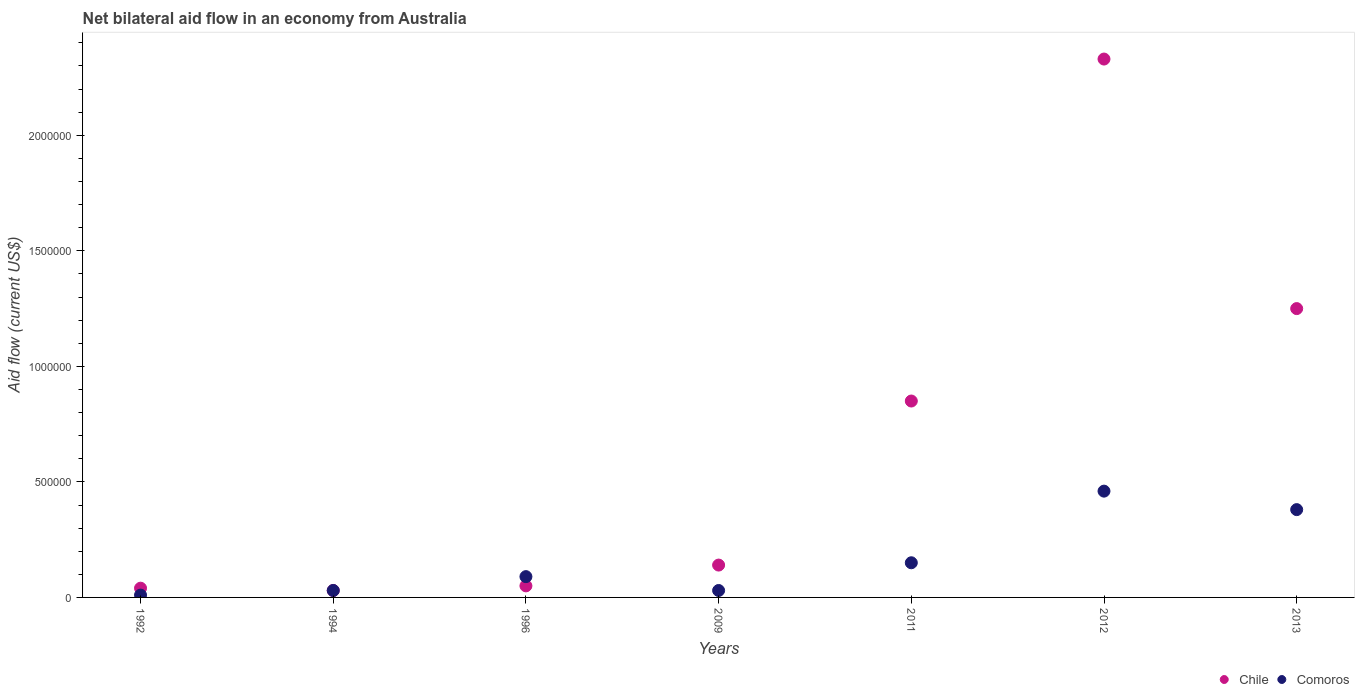What is the net bilateral aid flow in Chile in 2013?
Offer a very short reply. 1.25e+06. Across all years, what is the maximum net bilateral aid flow in Comoros?
Keep it short and to the point. 4.60e+05. In which year was the net bilateral aid flow in Comoros maximum?
Your answer should be compact. 2012. In which year was the net bilateral aid flow in Chile minimum?
Your answer should be compact. 1994. What is the total net bilateral aid flow in Chile in the graph?
Make the answer very short. 4.69e+06. What is the difference between the net bilateral aid flow in Chile in 2011 and the net bilateral aid flow in Comoros in 2013?
Your answer should be compact. 4.70e+05. What is the average net bilateral aid flow in Comoros per year?
Provide a short and direct response. 1.64e+05. What is the ratio of the net bilateral aid flow in Chile in 1992 to that in 2011?
Your answer should be compact. 0.05. What is the difference between the highest and the second highest net bilateral aid flow in Chile?
Your response must be concise. 1.08e+06. Is the sum of the net bilateral aid flow in Comoros in 2011 and 2013 greater than the maximum net bilateral aid flow in Chile across all years?
Offer a terse response. No. Does the net bilateral aid flow in Chile monotonically increase over the years?
Your answer should be compact. No. Is the net bilateral aid flow in Comoros strictly less than the net bilateral aid flow in Chile over the years?
Keep it short and to the point. No. How many legend labels are there?
Your answer should be compact. 2. What is the title of the graph?
Give a very brief answer. Net bilateral aid flow in an economy from Australia. What is the label or title of the Y-axis?
Ensure brevity in your answer.  Aid flow (current US$). What is the Aid flow (current US$) of Chile in 1992?
Provide a succinct answer. 4.00e+04. What is the Aid flow (current US$) in Comoros in 1992?
Offer a terse response. 10000. What is the Aid flow (current US$) in Chile in 1994?
Give a very brief answer. 3.00e+04. What is the Aid flow (current US$) in Comoros in 1994?
Make the answer very short. 3.00e+04. What is the Aid flow (current US$) of Comoros in 1996?
Offer a very short reply. 9.00e+04. What is the Aid flow (current US$) of Comoros in 2009?
Your answer should be compact. 3.00e+04. What is the Aid flow (current US$) in Chile in 2011?
Make the answer very short. 8.50e+05. What is the Aid flow (current US$) of Comoros in 2011?
Keep it short and to the point. 1.50e+05. What is the Aid flow (current US$) of Chile in 2012?
Your answer should be very brief. 2.33e+06. What is the Aid flow (current US$) of Comoros in 2012?
Ensure brevity in your answer.  4.60e+05. What is the Aid flow (current US$) in Chile in 2013?
Offer a terse response. 1.25e+06. Across all years, what is the maximum Aid flow (current US$) of Chile?
Your answer should be compact. 2.33e+06. Across all years, what is the minimum Aid flow (current US$) of Comoros?
Your response must be concise. 10000. What is the total Aid flow (current US$) in Chile in the graph?
Give a very brief answer. 4.69e+06. What is the total Aid flow (current US$) in Comoros in the graph?
Offer a very short reply. 1.15e+06. What is the difference between the Aid flow (current US$) of Chile in 1992 and that in 1994?
Keep it short and to the point. 10000. What is the difference between the Aid flow (current US$) in Chile in 1992 and that in 1996?
Keep it short and to the point. -10000. What is the difference between the Aid flow (current US$) of Chile in 1992 and that in 2011?
Your answer should be compact. -8.10e+05. What is the difference between the Aid flow (current US$) of Comoros in 1992 and that in 2011?
Provide a short and direct response. -1.40e+05. What is the difference between the Aid flow (current US$) in Chile in 1992 and that in 2012?
Your answer should be very brief. -2.29e+06. What is the difference between the Aid flow (current US$) in Comoros in 1992 and that in 2012?
Your answer should be very brief. -4.50e+05. What is the difference between the Aid flow (current US$) in Chile in 1992 and that in 2013?
Your answer should be very brief. -1.21e+06. What is the difference between the Aid flow (current US$) in Comoros in 1992 and that in 2013?
Provide a short and direct response. -3.70e+05. What is the difference between the Aid flow (current US$) of Chile in 1994 and that in 1996?
Your response must be concise. -2.00e+04. What is the difference between the Aid flow (current US$) in Comoros in 1994 and that in 1996?
Your answer should be compact. -6.00e+04. What is the difference between the Aid flow (current US$) in Chile in 1994 and that in 2009?
Ensure brevity in your answer.  -1.10e+05. What is the difference between the Aid flow (current US$) of Comoros in 1994 and that in 2009?
Provide a succinct answer. 0. What is the difference between the Aid flow (current US$) in Chile in 1994 and that in 2011?
Ensure brevity in your answer.  -8.20e+05. What is the difference between the Aid flow (current US$) in Comoros in 1994 and that in 2011?
Your response must be concise. -1.20e+05. What is the difference between the Aid flow (current US$) of Chile in 1994 and that in 2012?
Keep it short and to the point. -2.30e+06. What is the difference between the Aid flow (current US$) of Comoros in 1994 and that in 2012?
Provide a short and direct response. -4.30e+05. What is the difference between the Aid flow (current US$) in Chile in 1994 and that in 2013?
Make the answer very short. -1.22e+06. What is the difference between the Aid flow (current US$) of Comoros in 1994 and that in 2013?
Your response must be concise. -3.50e+05. What is the difference between the Aid flow (current US$) of Comoros in 1996 and that in 2009?
Your response must be concise. 6.00e+04. What is the difference between the Aid flow (current US$) of Chile in 1996 and that in 2011?
Provide a short and direct response. -8.00e+05. What is the difference between the Aid flow (current US$) of Chile in 1996 and that in 2012?
Give a very brief answer. -2.28e+06. What is the difference between the Aid flow (current US$) in Comoros in 1996 and that in 2012?
Provide a short and direct response. -3.70e+05. What is the difference between the Aid flow (current US$) of Chile in 1996 and that in 2013?
Make the answer very short. -1.20e+06. What is the difference between the Aid flow (current US$) in Comoros in 1996 and that in 2013?
Keep it short and to the point. -2.90e+05. What is the difference between the Aid flow (current US$) of Chile in 2009 and that in 2011?
Your response must be concise. -7.10e+05. What is the difference between the Aid flow (current US$) of Chile in 2009 and that in 2012?
Keep it short and to the point. -2.19e+06. What is the difference between the Aid flow (current US$) in Comoros in 2009 and that in 2012?
Ensure brevity in your answer.  -4.30e+05. What is the difference between the Aid flow (current US$) in Chile in 2009 and that in 2013?
Give a very brief answer. -1.11e+06. What is the difference between the Aid flow (current US$) of Comoros in 2009 and that in 2013?
Offer a terse response. -3.50e+05. What is the difference between the Aid flow (current US$) in Chile in 2011 and that in 2012?
Ensure brevity in your answer.  -1.48e+06. What is the difference between the Aid flow (current US$) in Comoros in 2011 and that in 2012?
Your answer should be very brief. -3.10e+05. What is the difference between the Aid flow (current US$) in Chile in 2011 and that in 2013?
Your answer should be very brief. -4.00e+05. What is the difference between the Aid flow (current US$) in Comoros in 2011 and that in 2013?
Ensure brevity in your answer.  -2.30e+05. What is the difference between the Aid flow (current US$) of Chile in 2012 and that in 2013?
Provide a short and direct response. 1.08e+06. What is the difference between the Aid flow (current US$) in Chile in 1992 and the Aid flow (current US$) in Comoros in 1994?
Make the answer very short. 10000. What is the difference between the Aid flow (current US$) of Chile in 1992 and the Aid flow (current US$) of Comoros in 2009?
Keep it short and to the point. 10000. What is the difference between the Aid flow (current US$) in Chile in 1992 and the Aid flow (current US$) in Comoros in 2011?
Your answer should be very brief. -1.10e+05. What is the difference between the Aid flow (current US$) in Chile in 1992 and the Aid flow (current US$) in Comoros in 2012?
Offer a terse response. -4.20e+05. What is the difference between the Aid flow (current US$) in Chile in 1994 and the Aid flow (current US$) in Comoros in 2012?
Offer a terse response. -4.30e+05. What is the difference between the Aid flow (current US$) of Chile in 1994 and the Aid flow (current US$) of Comoros in 2013?
Offer a very short reply. -3.50e+05. What is the difference between the Aid flow (current US$) in Chile in 1996 and the Aid flow (current US$) in Comoros in 2012?
Offer a very short reply. -4.10e+05. What is the difference between the Aid flow (current US$) in Chile in 1996 and the Aid flow (current US$) in Comoros in 2013?
Make the answer very short. -3.30e+05. What is the difference between the Aid flow (current US$) in Chile in 2009 and the Aid flow (current US$) in Comoros in 2011?
Make the answer very short. -10000. What is the difference between the Aid flow (current US$) in Chile in 2009 and the Aid flow (current US$) in Comoros in 2012?
Give a very brief answer. -3.20e+05. What is the difference between the Aid flow (current US$) in Chile in 2009 and the Aid flow (current US$) in Comoros in 2013?
Provide a short and direct response. -2.40e+05. What is the difference between the Aid flow (current US$) in Chile in 2011 and the Aid flow (current US$) in Comoros in 2012?
Your answer should be compact. 3.90e+05. What is the difference between the Aid flow (current US$) in Chile in 2012 and the Aid flow (current US$) in Comoros in 2013?
Offer a terse response. 1.95e+06. What is the average Aid flow (current US$) of Chile per year?
Ensure brevity in your answer.  6.70e+05. What is the average Aid flow (current US$) of Comoros per year?
Provide a succinct answer. 1.64e+05. In the year 1992, what is the difference between the Aid flow (current US$) in Chile and Aid flow (current US$) in Comoros?
Your answer should be compact. 3.00e+04. In the year 1996, what is the difference between the Aid flow (current US$) in Chile and Aid flow (current US$) in Comoros?
Your response must be concise. -4.00e+04. In the year 2009, what is the difference between the Aid flow (current US$) of Chile and Aid flow (current US$) of Comoros?
Keep it short and to the point. 1.10e+05. In the year 2012, what is the difference between the Aid flow (current US$) of Chile and Aid flow (current US$) of Comoros?
Your response must be concise. 1.87e+06. In the year 2013, what is the difference between the Aid flow (current US$) of Chile and Aid flow (current US$) of Comoros?
Keep it short and to the point. 8.70e+05. What is the ratio of the Aid flow (current US$) in Chile in 1992 to that in 1994?
Your answer should be compact. 1.33. What is the ratio of the Aid flow (current US$) of Comoros in 1992 to that in 1994?
Keep it short and to the point. 0.33. What is the ratio of the Aid flow (current US$) in Chile in 1992 to that in 1996?
Ensure brevity in your answer.  0.8. What is the ratio of the Aid flow (current US$) of Chile in 1992 to that in 2009?
Ensure brevity in your answer.  0.29. What is the ratio of the Aid flow (current US$) in Chile in 1992 to that in 2011?
Your response must be concise. 0.05. What is the ratio of the Aid flow (current US$) in Comoros in 1992 to that in 2011?
Your answer should be very brief. 0.07. What is the ratio of the Aid flow (current US$) in Chile in 1992 to that in 2012?
Give a very brief answer. 0.02. What is the ratio of the Aid flow (current US$) in Comoros in 1992 to that in 2012?
Offer a terse response. 0.02. What is the ratio of the Aid flow (current US$) of Chile in 1992 to that in 2013?
Offer a very short reply. 0.03. What is the ratio of the Aid flow (current US$) in Comoros in 1992 to that in 2013?
Offer a terse response. 0.03. What is the ratio of the Aid flow (current US$) of Comoros in 1994 to that in 1996?
Provide a short and direct response. 0.33. What is the ratio of the Aid flow (current US$) of Chile in 1994 to that in 2009?
Your answer should be compact. 0.21. What is the ratio of the Aid flow (current US$) in Comoros in 1994 to that in 2009?
Your response must be concise. 1. What is the ratio of the Aid flow (current US$) in Chile in 1994 to that in 2011?
Provide a short and direct response. 0.04. What is the ratio of the Aid flow (current US$) of Comoros in 1994 to that in 2011?
Ensure brevity in your answer.  0.2. What is the ratio of the Aid flow (current US$) in Chile in 1994 to that in 2012?
Keep it short and to the point. 0.01. What is the ratio of the Aid flow (current US$) of Comoros in 1994 to that in 2012?
Your answer should be compact. 0.07. What is the ratio of the Aid flow (current US$) in Chile in 1994 to that in 2013?
Provide a short and direct response. 0.02. What is the ratio of the Aid flow (current US$) of Comoros in 1994 to that in 2013?
Give a very brief answer. 0.08. What is the ratio of the Aid flow (current US$) of Chile in 1996 to that in 2009?
Ensure brevity in your answer.  0.36. What is the ratio of the Aid flow (current US$) in Comoros in 1996 to that in 2009?
Make the answer very short. 3. What is the ratio of the Aid flow (current US$) of Chile in 1996 to that in 2011?
Provide a short and direct response. 0.06. What is the ratio of the Aid flow (current US$) of Comoros in 1996 to that in 2011?
Your response must be concise. 0.6. What is the ratio of the Aid flow (current US$) in Chile in 1996 to that in 2012?
Provide a short and direct response. 0.02. What is the ratio of the Aid flow (current US$) in Comoros in 1996 to that in 2012?
Make the answer very short. 0.2. What is the ratio of the Aid flow (current US$) in Comoros in 1996 to that in 2013?
Give a very brief answer. 0.24. What is the ratio of the Aid flow (current US$) of Chile in 2009 to that in 2011?
Provide a succinct answer. 0.16. What is the ratio of the Aid flow (current US$) of Chile in 2009 to that in 2012?
Your response must be concise. 0.06. What is the ratio of the Aid flow (current US$) of Comoros in 2009 to that in 2012?
Your response must be concise. 0.07. What is the ratio of the Aid flow (current US$) in Chile in 2009 to that in 2013?
Keep it short and to the point. 0.11. What is the ratio of the Aid flow (current US$) in Comoros in 2009 to that in 2013?
Offer a very short reply. 0.08. What is the ratio of the Aid flow (current US$) of Chile in 2011 to that in 2012?
Make the answer very short. 0.36. What is the ratio of the Aid flow (current US$) in Comoros in 2011 to that in 2012?
Give a very brief answer. 0.33. What is the ratio of the Aid flow (current US$) of Chile in 2011 to that in 2013?
Your answer should be compact. 0.68. What is the ratio of the Aid flow (current US$) of Comoros in 2011 to that in 2013?
Offer a very short reply. 0.39. What is the ratio of the Aid flow (current US$) in Chile in 2012 to that in 2013?
Offer a terse response. 1.86. What is the ratio of the Aid flow (current US$) in Comoros in 2012 to that in 2013?
Provide a succinct answer. 1.21. What is the difference between the highest and the second highest Aid flow (current US$) in Chile?
Keep it short and to the point. 1.08e+06. What is the difference between the highest and the lowest Aid flow (current US$) of Chile?
Ensure brevity in your answer.  2.30e+06. 